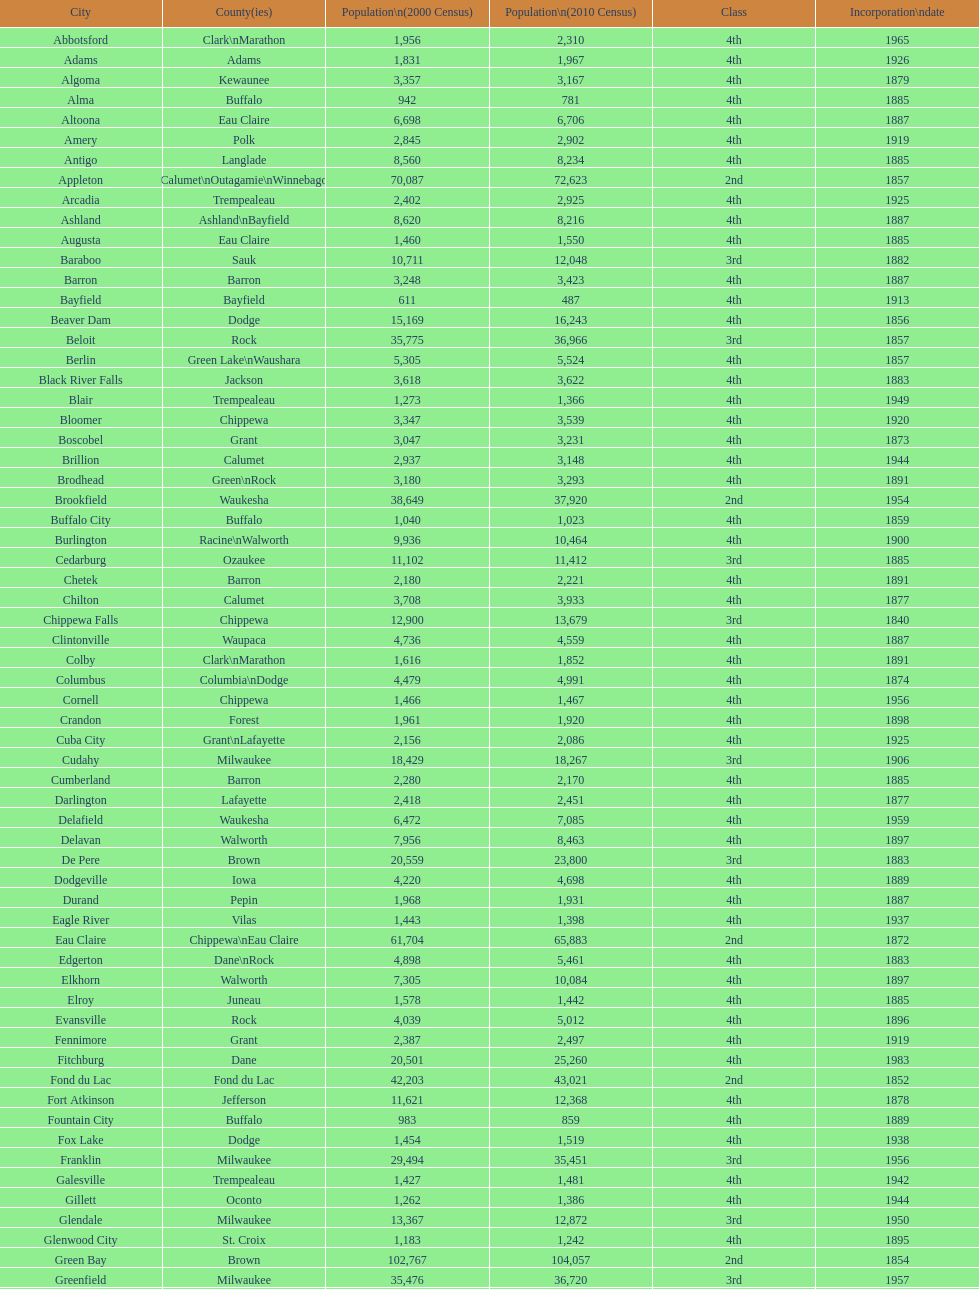In how many cities does the incorporation date correspond to 1926? 2. 